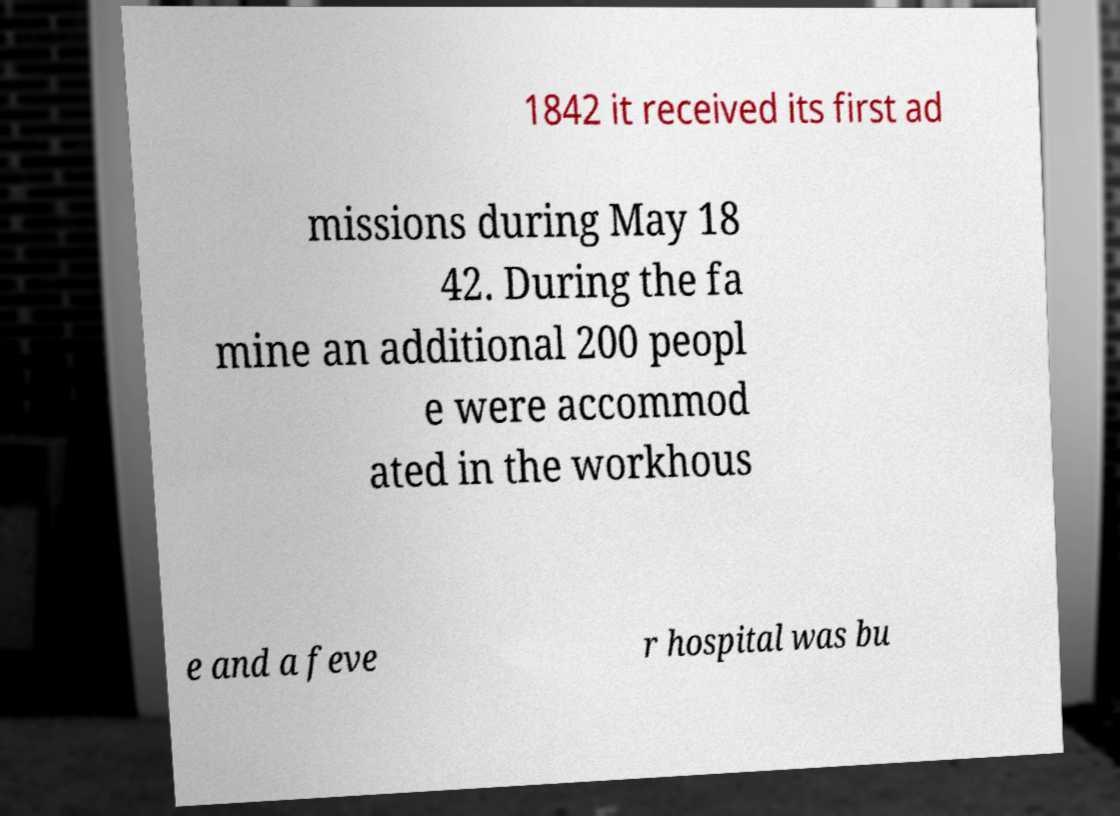Could you extract and type out the text from this image? 1842 it received its first ad missions during May 18 42. During the fa mine an additional 200 peopl e were accommod ated in the workhous e and a feve r hospital was bu 